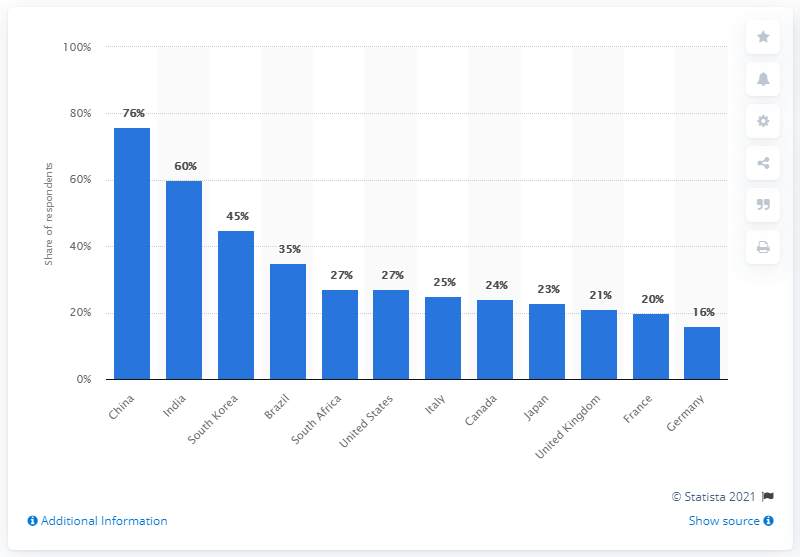Indicate a few pertinent items in this graphic. According to the survey, 16% of Germans stated that they convinced others to stop using a brand because it was not responding well to the COVID-19 outbreak. 